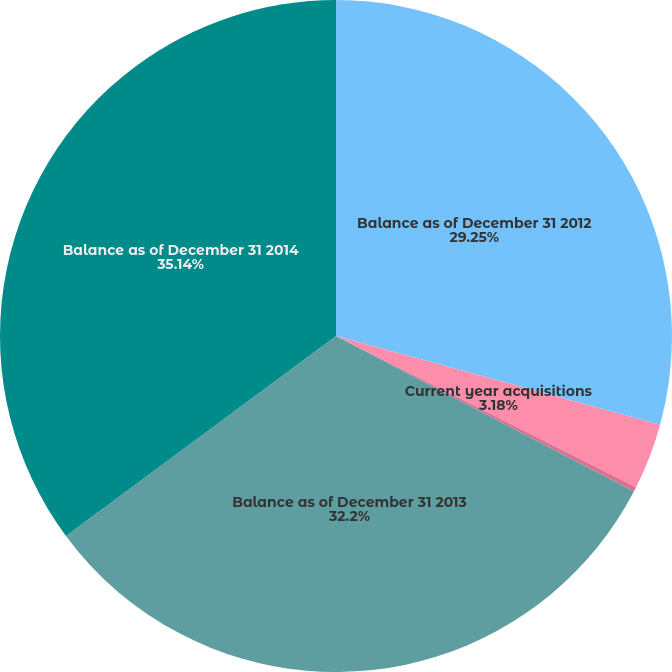Convert chart to OTSL. <chart><loc_0><loc_0><loc_500><loc_500><pie_chart><fcel>Balance as of December 31 2012<fcel>Current year acquisitions<fcel>Foreign currency and other<fcel>Balance as of December 31 2013<fcel>Balance as of December 31 2014<nl><fcel>29.25%<fcel>3.18%<fcel>0.23%<fcel>32.2%<fcel>35.14%<nl></chart> 